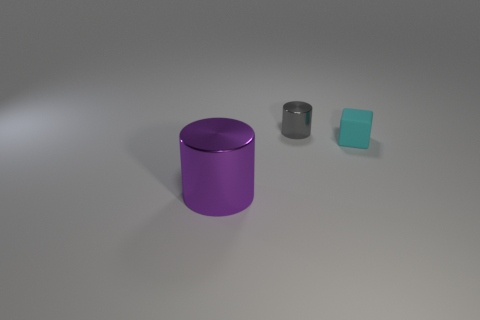Is there anything else that is the same material as the tiny cyan cube?
Your response must be concise. No. Is there anything else that is the same size as the purple shiny object?
Ensure brevity in your answer.  No. What is the color of the large cylinder?
Your response must be concise. Purple. Is the shape of the shiny thing behind the purple metallic cylinder the same as the metal object in front of the gray object?
Provide a short and direct response. Yes. There is a thing that is both in front of the tiny gray cylinder and to the left of the tiny cyan matte cube; what is its color?
Offer a very short reply. Purple. What size is the thing that is to the left of the block and in front of the tiny cylinder?
Offer a terse response. Large. What number of other things are the same color as the matte object?
Offer a very short reply. 0. What is the size of the metallic object that is in front of the shiny thing that is behind the shiny cylinder that is in front of the small rubber object?
Offer a very short reply. Large. Are there any purple things left of the purple metallic thing?
Provide a succinct answer. No. Does the gray shiny thing have the same size as the shiny cylinder in front of the rubber block?
Offer a terse response. No. 